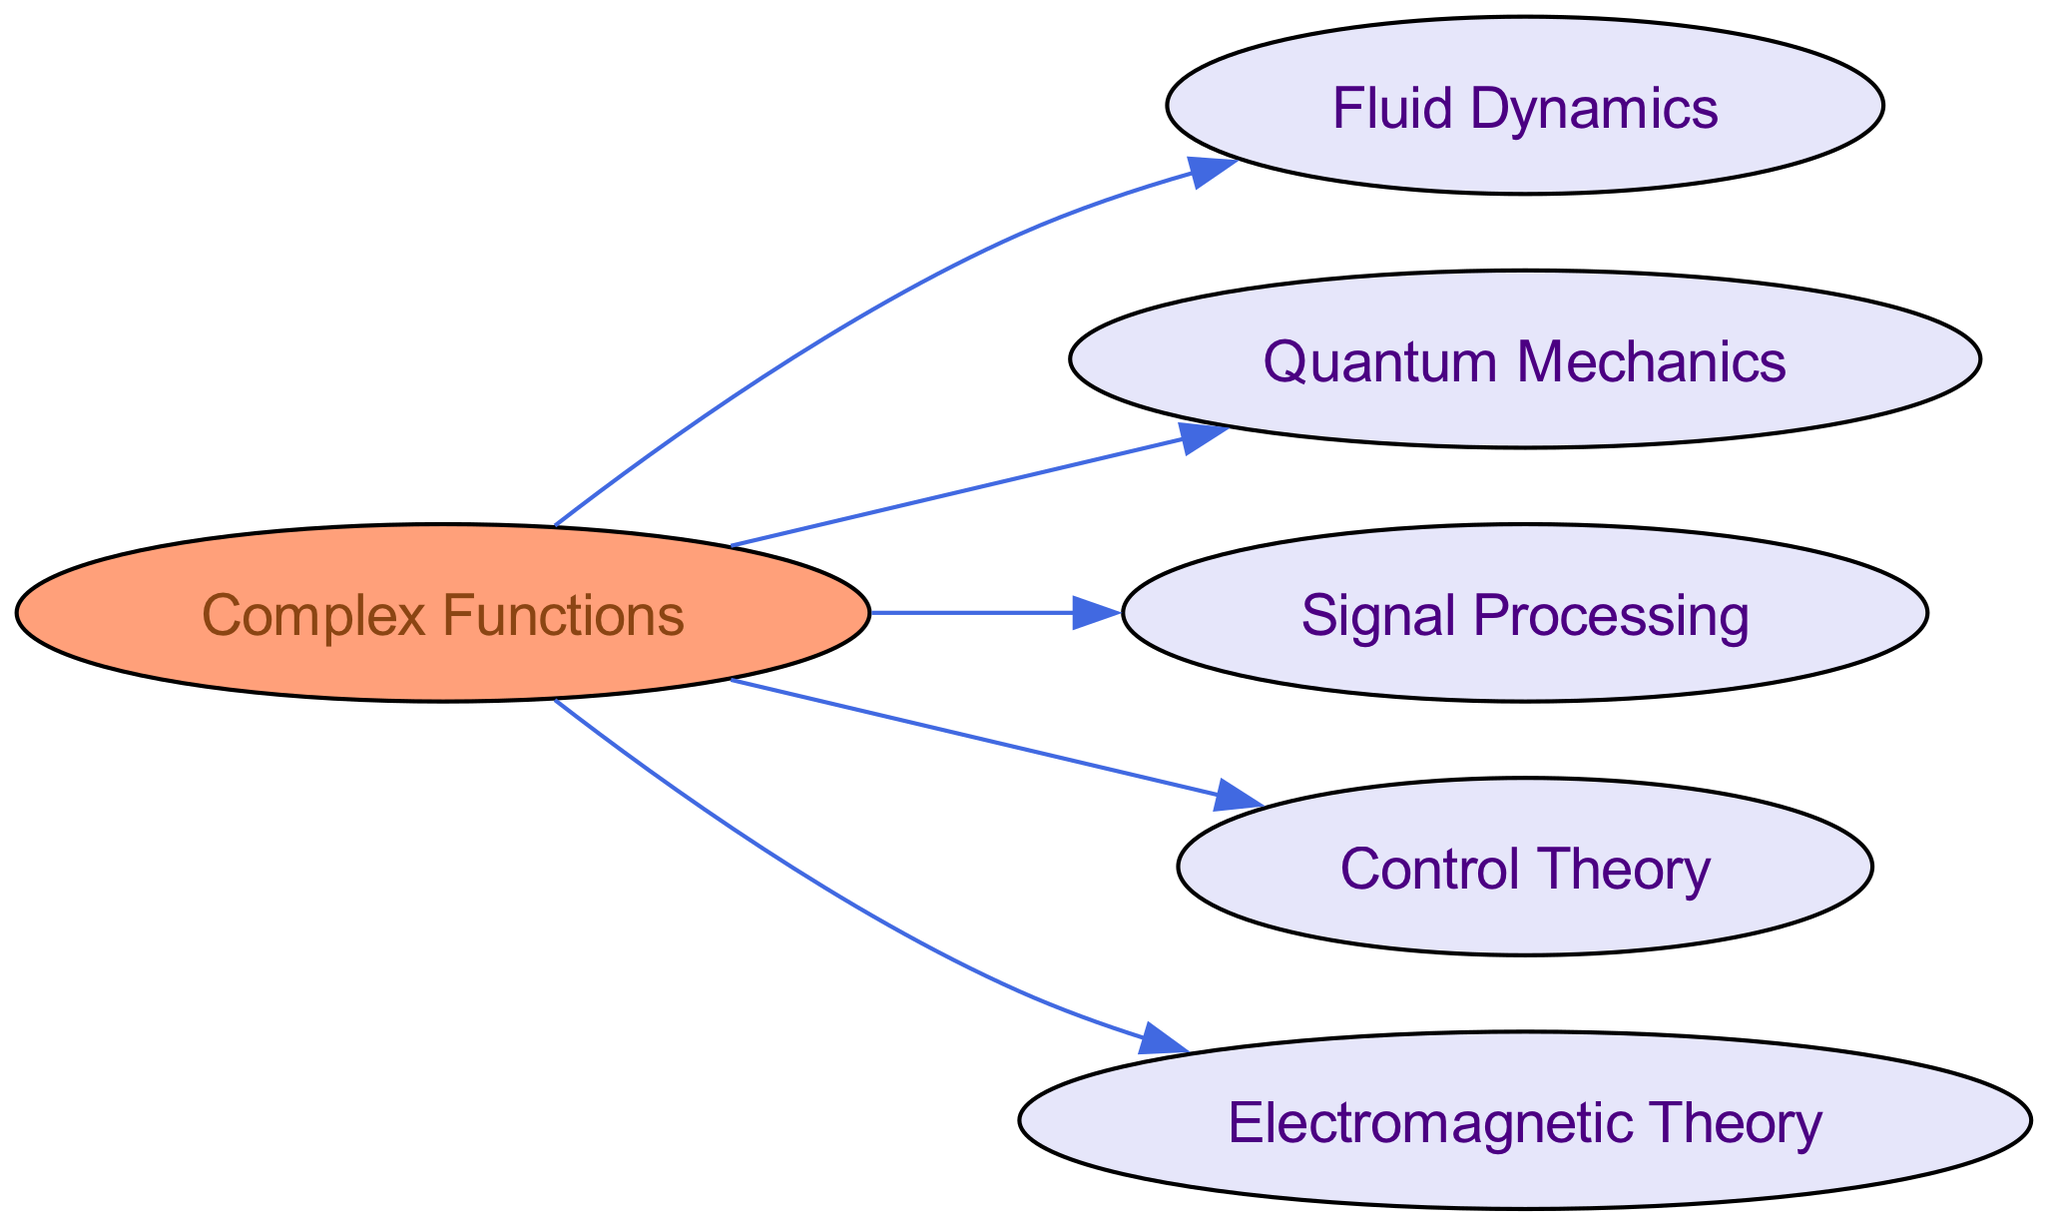What is the main node in the diagram? The main or primary node is typically the one that connects to multiple other nodes. In this diagram, "Complex Functions" serves as the main node as it has outgoing connections to other disciplines, indicating its foundational role.
Answer: Complex Functions How many total nodes are present in the directed graph? The total number of nodes can be counted directly from the visual representation of the diagram. There are six nodes listed: "Complex Functions," "Fluid Dynamics," "Quantum Mechanics," "Signal Processing," "Control Theory," and "Electromagnetic Theory."
Answer: 6 Which field is directly influenced by "Complex Functions"? To identify fields influenced by "Complex Functions," look for nodes that have directed edges leading from "Complex Functions." The edges point from "Complex Functions" to "Fluid Dynamics," "Quantum Mechanics," "Signal Processing," "Control Theory," and "Electromagnetic Theory."
Answer: Fluid Dynamics, Quantum Mechanics, Signal Processing, Control Theory, Electromagnetic Theory What is the relationship direction from "Complex Functions" to "Control Theory"? The direction of the relationship can be determined by observing the arrow in the directed graph. The arrow pointing from "Complex Functions" to "Control Theory" indicates that "Complex Functions" influences or is applied in "Control Theory."
Answer: From Complex Functions to Control Theory Which node has the most connections in the graph? The node with the most connections can be identified by examining the number of edges directed to each node. In this graph, "Complex Functions" has outgoing edges connecting to five different nodes, while the other nodes do not connect outward.
Answer: Complex Functions How many edges are there in the diagram? To find the number of edges, simply count the arrows connecting the nodes. There are five edges directed from "Complex Functions" to each of the other fields listed in the diagram.
Answer: 5 Which field is the least connected in the graph? The least connected field can be determined by checking the number of incoming or outgoing connections. In this graph, none of the nodes (except "Complex Functions") have connections leading to other nodes, indicating they do not influence others. Each is only influenced by "Complex Functions."
Answer: All other fields are equally least connected What type of graph is represented in this diagram? The type of graph represented can be classified based on the direction of the connections. Since the edges have a clear direction from a single node to others without reciprocation, it is a directed graph.
Answer: Directed Graph Are there any fields that connect to multiple other fields? To answer this question, one must check for nodes that have multiple outgoing edges. In this case, "Complex Functions" connects to five fields, while no others connect further; therefore, there are no fields connecting to multiple other fields.
Answer: No 